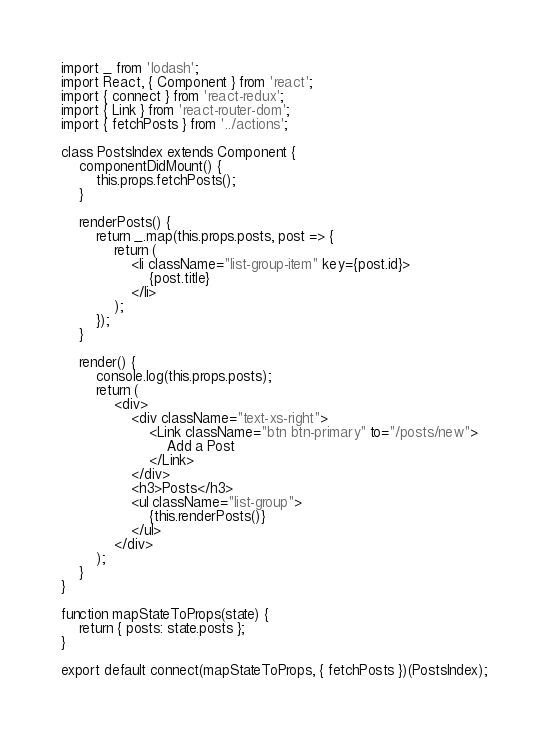Convert code to text. <code><loc_0><loc_0><loc_500><loc_500><_JavaScript_>import _ from 'lodash';
import React, { Component } from 'react';
import { connect } from 'react-redux';
import { Link } from 'react-router-dom';
import { fetchPosts } from '../actions';

class PostsIndex extends Component {
	componentDidMount() {
		this.props.fetchPosts();
	}

	renderPosts() {
		return _.map(this.props.posts, post => {
			return (
				<li className="list-group-item" key={post.id}>
					{post.title}
				</li>
			);
		});
	}

	render() {
		console.log(this.props.posts);
		return (
			<div>
				<div className="text-xs-right">
					<Link className="btn btn-primary" to="/posts/new">
						Add a Post
					</Link>
				</div>
				<h3>Posts</h3>
				<ul className="list-group">
					{this.renderPosts()}
				</ul>
			</div>
		);
	}
}

function mapStateToProps(state) {
	return { posts: state.posts };
}

export default connect(mapStateToProps, { fetchPosts })(PostsIndex);
</code> 